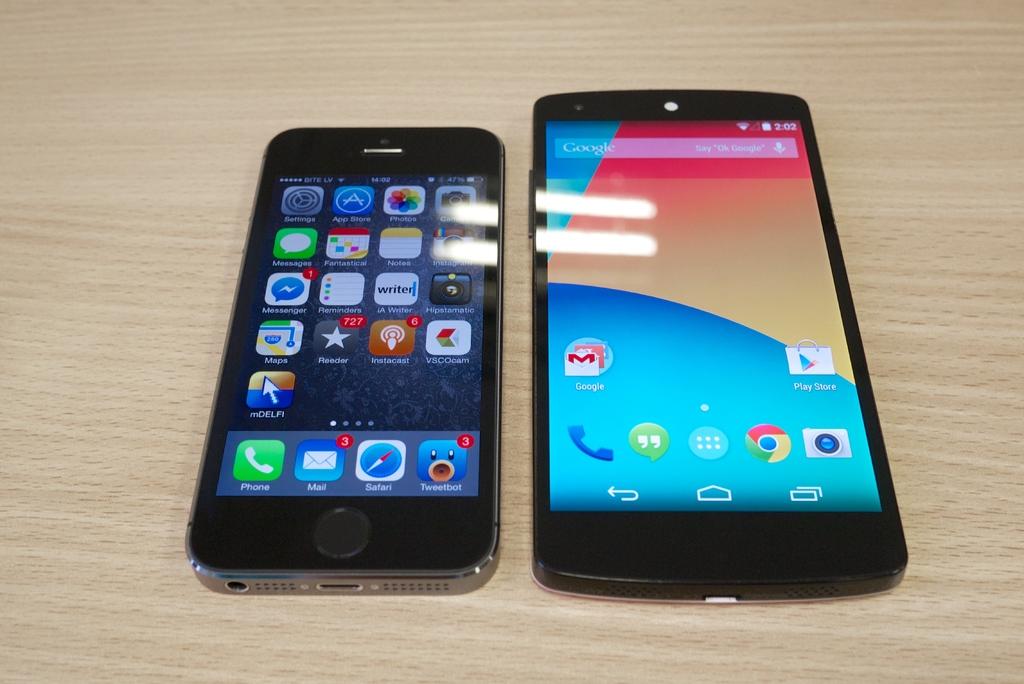How many emails does the phone on the left have?
Your answer should be compact. 3. What search engine is on the phone on the right?
Provide a short and direct response. Google. 